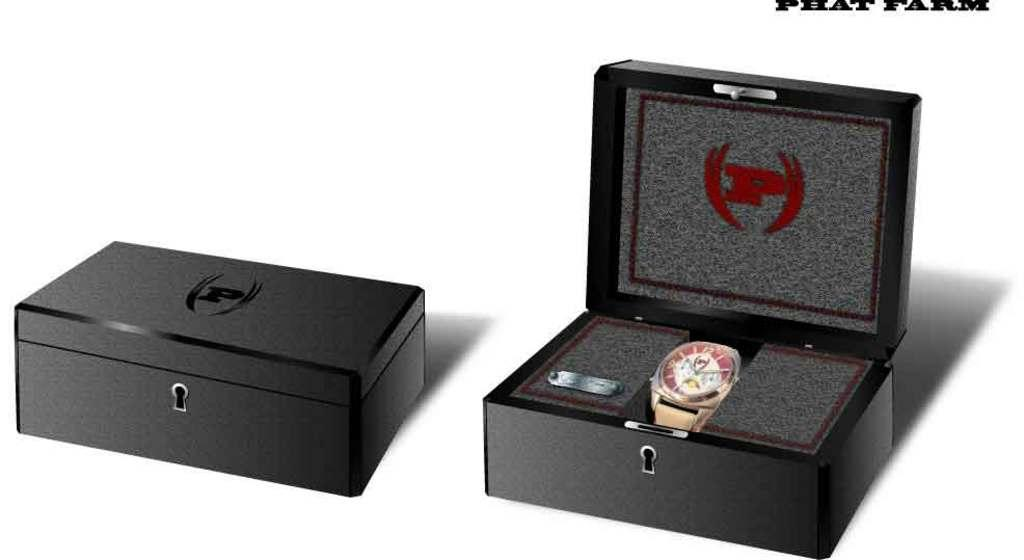<image>
Provide a brief description of the given image. Two boxes one is open with a watch inside it and under the lid is the letter P. 